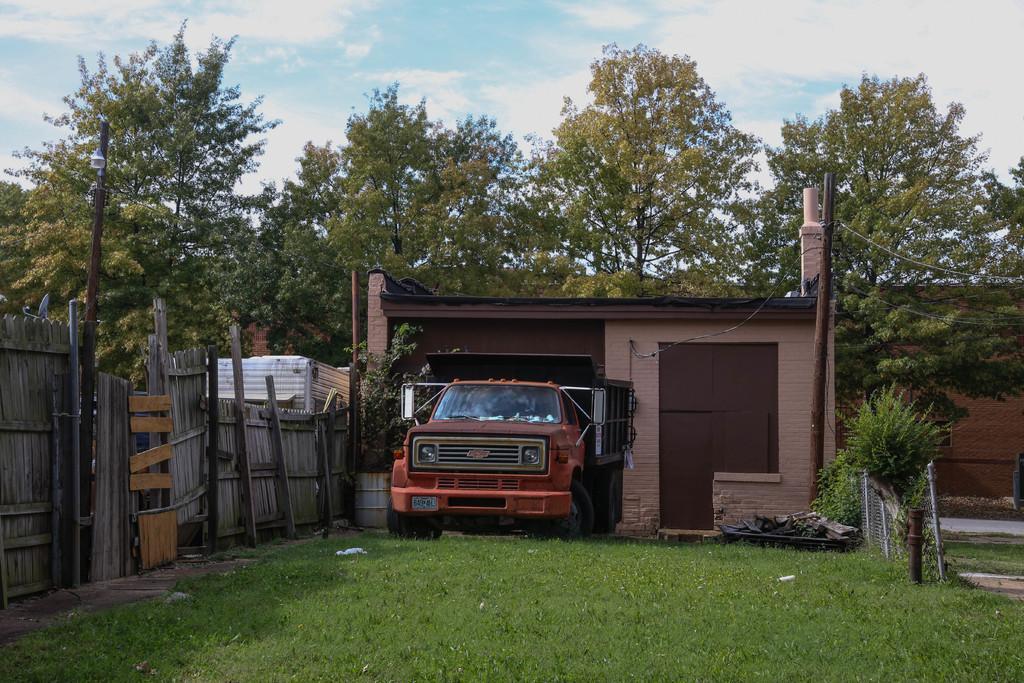Can you describe this image briefly? In the middle of the image we can see a truck on the grass, in the background we can see few trees, cables and clouds, on the right side of the image we can see fence. 